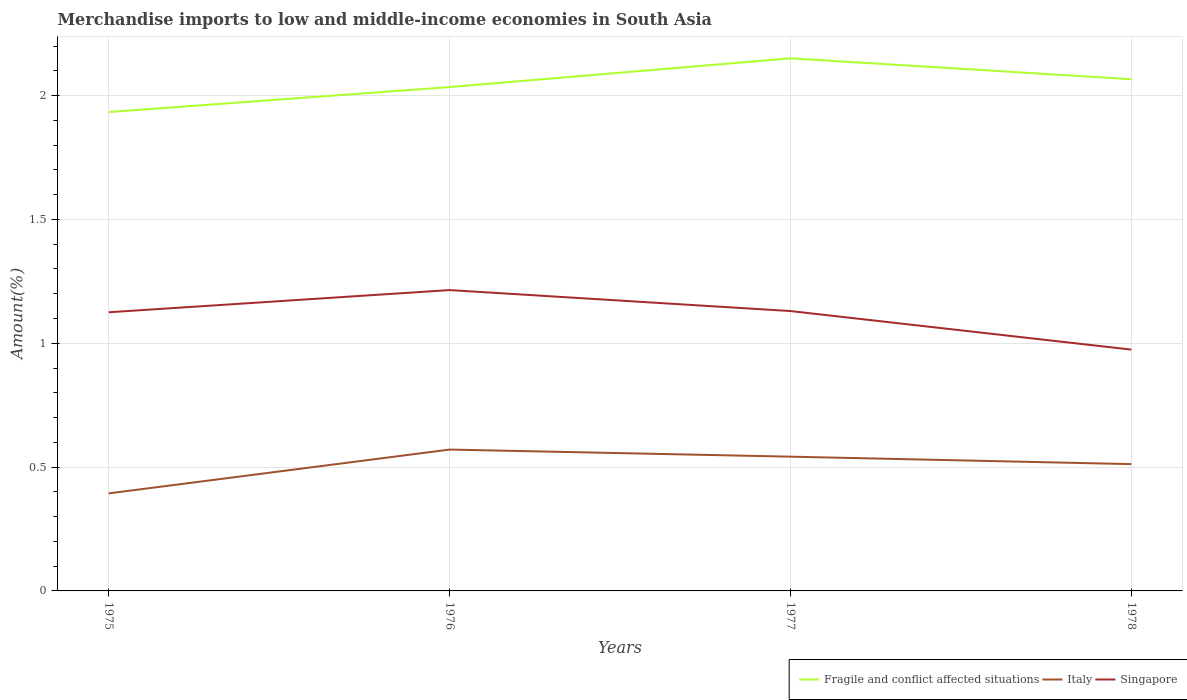Does the line corresponding to Singapore intersect with the line corresponding to Fragile and conflict affected situations?
Offer a terse response. No. Across all years, what is the maximum percentage of amount earned from merchandise imports in Fragile and conflict affected situations?
Offer a terse response. 1.93. In which year was the percentage of amount earned from merchandise imports in Singapore maximum?
Make the answer very short. 1978. What is the total percentage of amount earned from merchandise imports in Singapore in the graph?
Keep it short and to the point. 0.16. What is the difference between the highest and the second highest percentage of amount earned from merchandise imports in Fragile and conflict affected situations?
Your answer should be very brief. 0.22. What is the difference between the highest and the lowest percentage of amount earned from merchandise imports in Italy?
Offer a terse response. 3. Are the values on the major ticks of Y-axis written in scientific E-notation?
Your response must be concise. No. Does the graph contain any zero values?
Your answer should be compact. No. Where does the legend appear in the graph?
Your response must be concise. Bottom right. What is the title of the graph?
Offer a very short reply. Merchandise imports to low and middle-income economies in South Asia. Does "Jordan" appear as one of the legend labels in the graph?
Your response must be concise. No. What is the label or title of the Y-axis?
Your response must be concise. Amount(%). What is the Amount(%) of Fragile and conflict affected situations in 1975?
Offer a very short reply. 1.93. What is the Amount(%) in Italy in 1975?
Make the answer very short. 0.39. What is the Amount(%) in Singapore in 1975?
Ensure brevity in your answer.  1.13. What is the Amount(%) of Fragile and conflict affected situations in 1976?
Make the answer very short. 2.03. What is the Amount(%) in Italy in 1976?
Offer a terse response. 0.57. What is the Amount(%) in Singapore in 1976?
Provide a succinct answer. 1.21. What is the Amount(%) in Fragile and conflict affected situations in 1977?
Your response must be concise. 2.15. What is the Amount(%) in Italy in 1977?
Make the answer very short. 0.54. What is the Amount(%) of Singapore in 1977?
Keep it short and to the point. 1.13. What is the Amount(%) in Fragile and conflict affected situations in 1978?
Provide a short and direct response. 2.07. What is the Amount(%) of Italy in 1978?
Offer a terse response. 0.51. What is the Amount(%) of Singapore in 1978?
Provide a short and direct response. 0.97. Across all years, what is the maximum Amount(%) of Fragile and conflict affected situations?
Make the answer very short. 2.15. Across all years, what is the maximum Amount(%) in Italy?
Offer a very short reply. 0.57. Across all years, what is the maximum Amount(%) of Singapore?
Keep it short and to the point. 1.21. Across all years, what is the minimum Amount(%) of Fragile and conflict affected situations?
Offer a very short reply. 1.93. Across all years, what is the minimum Amount(%) of Italy?
Offer a terse response. 0.39. Across all years, what is the minimum Amount(%) in Singapore?
Provide a succinct answer. 0.97. What is the total Amount(%) of Fragile and conflict affected situations in the graph?
Keep it short and to the point. 8.19. What is the total Amount(%) of Italy in the graph?
Keep it short and to the point. 2.02. What is the total Amount(%) in Singapore in the graph?
Offer a terse response. 4.44. What is the difference between the Amount(%) of Fragile and conflict affected situations in 1975 and that in 1976?
Ensure brevity in your answer.  -0.1. What is the difference between the Amount(%) in Italy in 1975 and that in 1976?
Give a very brief answer. -0.18. What is the difference between the Amount(%) in Singapore in 1975 and that in 1976?
Your answer should be compact. -0.09. What is the difference between the Amount(%) of Fragile and conflict affected situations in 1975 and that in 1977?
Provide a short and direct response. -0.22. What is the difference between the Amount(%) of Italy in 1975 and that in 1977?
Offer a very short reply. -0.15. What is the difference between the Amount(%) of Singapore in 1975 and that in 1977?
Offer a terse response. -0. What is the difference between the Amount(%) of Fragile and conflict affected situations in 1975 and that in 1978?
Provide a short and direct response. -0.13. What is the difference between the Amount(%) of Italy in 1975 and that in 1978?
Make the answer very short. -0.12. What is the difference between the Amount(%) in Singapore in 1975 and that in 1978?
Your answer should be very brief. 0.15. What is the difference between the Amount(%) of Fragile and conflict affected situations in 1976 and that in 1977?
Your answer should be very brief. -0.12. What is the difference between the Amount(%) in Italy in 1976 and that in 1977?
Offer a terse response. 0.03. What is the difference between the Amount(%) of Singapore in 1976 and that in 1977?
Make the answer very short. 0.08. What is the difference between the Amount(%) of Fragile and conflict affected situations in 1976 and that in 1978?
Provide a short and direct response. -0.03. What is the difference between the Amount(%) of Italy in 1976 and that in 1978?
Your answer should be very brief. 0.06. What is the difference between the Amount(%) in Singapore in 1976 and that in 1978?
Keep it short and to the point. 0.24. What is the difference between the Amount(%) of Fragile and conflict affected situations in 1977 and that in 1978?
Offer a very short reply. 0.08. What is the difference between the Amount(%) of Italy in 1977 and that in 1978?
Offer a terse response. 0.03. What is the difference between the Amount(%) of Singapore in 1977 and that in 1978?
Provide a short and direct response. 0.16. What is the difference between the Amount(%) of Fragile and conflict affected situations in 1975 and the Amount(%) of Italy in 1976?
Offer a very short reply. 1.36. What is the difference between the Amount(%) in Fragile and conflict affected situations in 1975 and the Amount(%) in Singapore in 1976?
Your response must be concise. 0.72. What is the difference between the Amount(%) in Italy in 1975 and the Amount(%) in Singapore in 1976?
Keep it short and to the point. -0.82. What is the difference between the Amount(%) in Fragile and conflict affected situations in 1975 and the Amount(%) in Italy in 1977?
Your answer should be compact. 1.39. What is the difference between the Amount(%) in Fragile and conflict affected situations in 1975 and the Amount(%) in Singapore in 1977?
Make the answer very short. 0.8. What is the difference between the Amount(%) in Italy in 1975 and the Amount(%) in Singapore in 1977?
Ensure brevity in your answer.  -0.74. What is the difference between the Amount(%) in Fragile and conflict affected situations in 1975 and the Amount(%) in Italy in 1978?
Keep it short and to the point. 1.42. What is the difference between the Amount(%) in Fragile and conflict affected situations in 1975 and the Amount(%) in Singapore in 1978?
Keep it short and to the point. 0.96. What is the difference between the Amount(%) in Italy in 1975 and the Amount(%) in Singapore in 1978?
Give a very brief answer. -0.58. What is the difference between the Amount(%) in Fragile and conflict affected situations in 1976 and the Amount(%) in Italy in 1977?
Offer a very short reply. 1.49. What is the difference between the Amount(%) of Fragile and conflict affected situations in 1976 and the Amount(%) of Singapore in 1977?
Provide a short and direct response. 0.9. What is the difference between the Amount(%) of Italy in 1976 and the Amount(%) of Singapore in 1977?
Give a very brief answer. -0.56. What is the difference between the Amount(%) of Fragile and conflict affected situations in 1976 and the Amount(%) of Italy in 1978?
Your response must be concise. 1.52. What is the difference between the Amount(%) in Fragile and conflict affected situations in 1976 and the Amount(%) in Singapore in 1978?
Provide a short and direct response. 1.06. What is the difference between the Amount(%) in Italy in 1976 and the Amount(%) in Singapore in 1978?
Provide a short and direct response. -0.4. What is the difference between the Amount(%) of Fragile and conflict affected situations in 1977 and the Amount(%) of Italy in 1978?
Offer a very short reply. 1.64. What is the difference between the Amount(%) of Fragile and conflict affected situations in 1977 and the Amount(%) of Singapore in 1978?
Your answer should be very brief. 1.18. What is the difference between the Amount(%) in Italy in 1977 and the Amount(%) in Singapore in 1978?
Give a very brief answer. -0.43. What is the average Amount(%) of Fragile and conflict affected situations per year?
Keep it short and to the point. 2.05. What is the average Amount(%) in Italy per year?
Ensure brevity in your answer.  0.5. What is the average Amount(%) in Singapore per year?
Provide a succinct answer. 1.11. In the year 1975, what is the difference between the Amount(%) of Fragile and conflict affected situations and Amount(%) of Italy?
Give a very brief answer. 1.54. In the year 1975, what is the difference between the Amount(%) of Fragile and conflict affected situations and Amount(%) of Singapore?
Your answer should be compact. 0.81. In the year 1975, what is the difference between the Amount(%) of Italy and Amount(%) of Singapore?
Your answer should be compact. -0.73. In the year 1976, what is the difference between the Amount(%) in Fragile and conflict affected situations and Amount(%) in Italy?
Ensure brevity in your answer.  1.46. In the year 1976, what is the difference between the Amount(%) of Fragile and conflict affected situations and Amount(%) of Singapore?
Keep it short and to the point. 0.82. In the year 1976, what is the difference between the Amount(%) in Italy and Amount(%) in Singapore?
Your answer should be very brief. -0.64. In the year 1977, what is the difference between the Amount(%) in Fragile and conflict affected situations and Amount(%) in Italy?
Offer a terse response. 1.61. In the year 1977, what is the difference between the Amount(%) of Fragile and conflict affected situations and Amount(%) of Singapore?
Give a very brief answer. 1.02. In the year 1977, what is the difference between the Amount(%) in Italy and Amount(%) in Singapore?
Keep it short and to the point. -0.59. In the year 1978, what is the difference between the Amount(%) of Fragile and conflict affected situations and Amount(%) of Italy?
Your answer should be very brief. 1.55. In the year 1978, what is the difference between the Amount(%) of Fragile and conflict affected situations and Amount(%) of Singapore?
Offer a very short reply. 1.09. In the year 1978, what is the difference between the Amount(%) of Italy and Amount(%) of Singapore?
Offer a terse response. -0.46. What is the ratio of the Amount(%) of Fragile and conflict affected situations in 1975 to that in 1976?
Keep it short and to the point. 0.95. What is the ratio of the Amount(%) of Italy in 1975 to that in 1976?
Give a very brief answer. 0.69. What is the ratio of the Amount(%) in Singapore in 1975 to that in 1976?
Offer a very short reply. 0.93. What is the ratio of the Amount(%) of Fragile and conflict affected situations in 1975 to that in 1977?
Offer a very short reply. 0.9. What is the ratio of the Amount(%) of Italy in 1975 to that in 1977?
Make the answer very short. 0.73. What is the ratio of the Amount(%) of Fragile and conflict affected situations in 1975 to that in 1978?
Make the answer very short. 0.94. What is the ratio of the Amount(%) in Italy in 1975 to that in 1978?
Make the answer very short. 0.77. What is the ratio of the Amount(%) of Singapore in 1975 to that in 1978?
Keep it short and to the point. 1.15. What is the ratio of the Amount(%) of Fragile and conflict affected situations in 1976 to that in 1977?
Offer a very short reply. 0.95. What is the ratio of the Amount(%) in Italy in 1976 to that in 1977?
Provide a short and direct response. 1.05. What is the ratio of the Amount(%) of Singapore in 1976 to that in 1977?
Provide a succinct answer. 1.07. What is the ratio of the Amount(%) in Fragile and conflict affected situations in 1976 to that in 1978?
Keep it short and to the point. 0.98. What is the ratio of the Amount(%) of Italy in 1976 to that in 1978?
Make the answer very short. 1.11. What is the ratio of the Amount(%) of Singapore in 1976 to that in 1978?
Offer a very short reply. 1.25. What is the ratio of the Amount(%) of Fragile and conflict affected situations in 1977 to that in 1978?
Provide a succinct answer. 1.04. What is the ratio of the Amount(%) in Italy in 1977 to that in 1978?
Keep it short and to the point. 1.06. What is the ratio of the Amount(%) in Singapore in 1977 to that in 1978?
Offer a terse response. 1.16. What is the difference between the highest and the second highest Amount(%) of Fragile and conflict affected situations?
Offer a terse response. 0.08. What is the difference between the highest and the second highest Amount(%) of Italy?
Your answer should be very brief. 0.03. What is the difference between the highest and the second highest Amount(%) of Singapore?
Make the answer very short. 0.08. What is the difference between the highest and the lowest Amount(%) of Fragile and conflict affected situations?
Ensure brevity in your answer.  0.22. What is the difference between the highest and the lowest Amount(%) of Italy?
Make the answer very short. 0.18. What is the difference between the highest and the lowest Amount(%) in Singapore?
Provide a short and direct response. 0.24. 